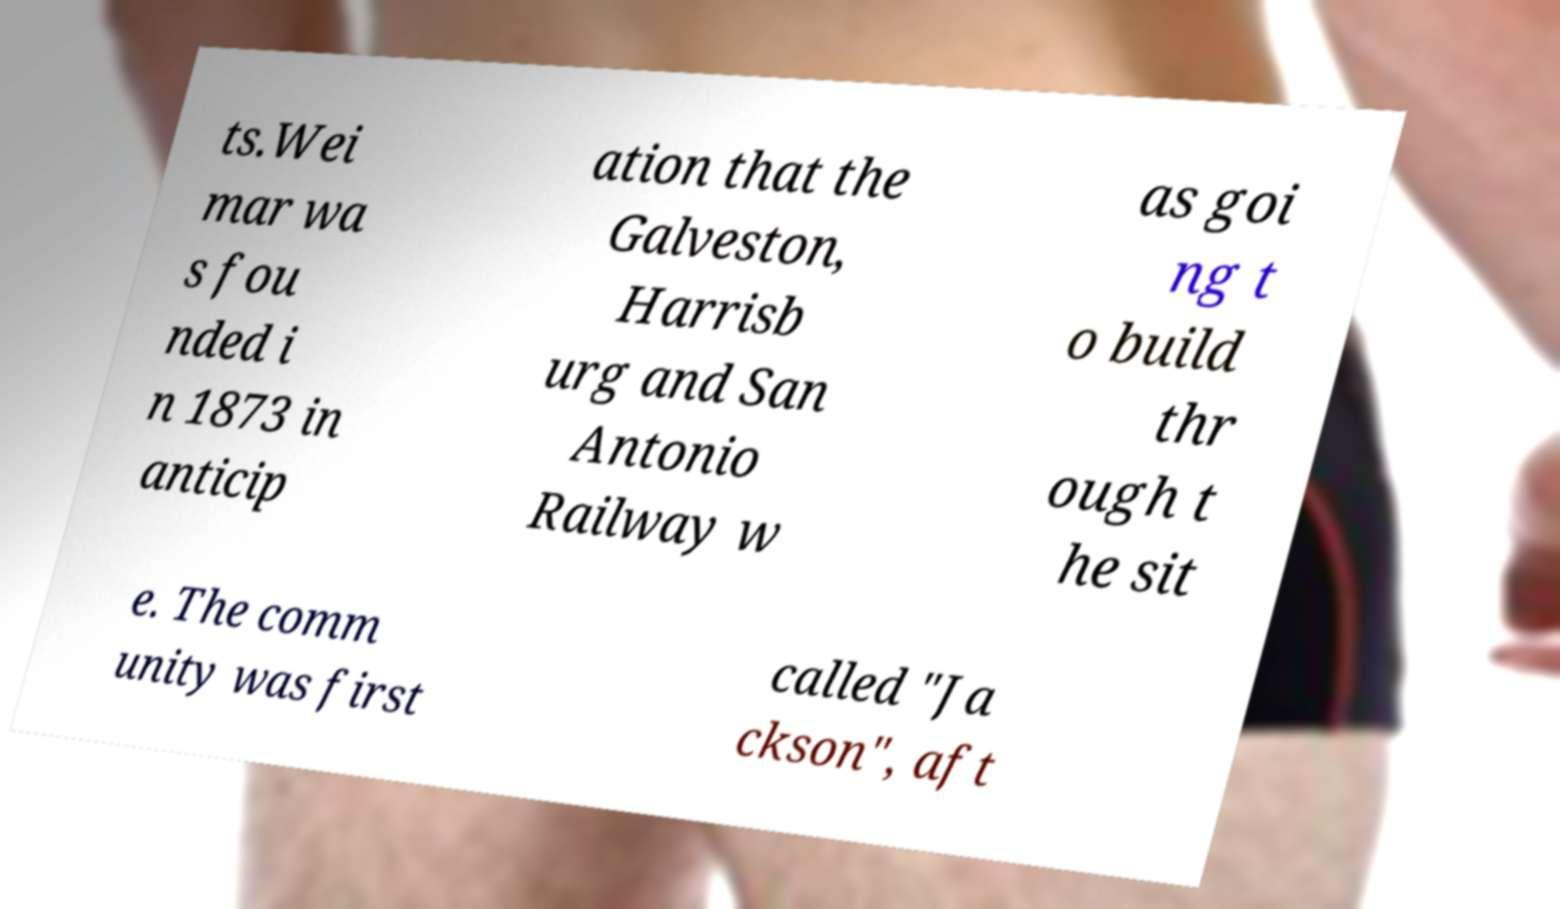For documentation purposes, I need the text within this image transcribed. Could you provide that? ts.Wei mar wa s fou nded i n 1873 in anticip ation that the Galveston, Harrisb urg and San Antonio Railway w as goi ng t o build thr ough t he sit e. The comm unity was first called "Ja ckson", aft 